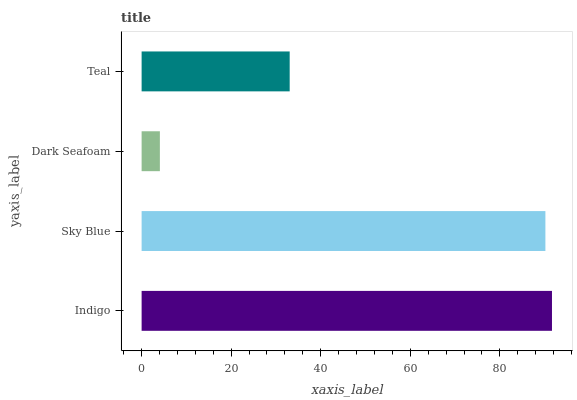Is Dark Seafoam the minimum?
Answer yes or no. Yes. Is Indigo the maximum?
Answer yes or no. Yes. Is Sky Blue the minimum?
Answer yes or no. No. Is Sky Blue the maximum?
Answer yes or no. No. Is Indigo greater than Sky Blue?
Answer yes or no. Yes. Is Sky Blue less than Indigo?
Answer yes or no. Yes. Is Sky Blue greater than Indigo?
Answer yes or no. No. Is Indigo less than Sky Blue?
Answer yes or no. No. Is Sky Blue the high median?
Answer yes or no. Yes. Is Teal the low median?
Answer yes or no. Yes. Is Indigo the high median?
Answer yes or no. No. Is Sky Blue the low median?
Answer yes or no. No. 